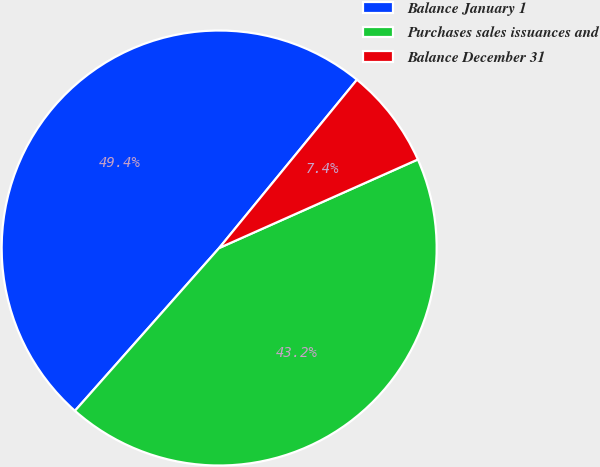<chart> <loc_0><loc_0><loc_500><loc_500><pie_chart><fcel>Balance January 1<fcel>Purchases sales issuances and<fcel>Balance December 31<nl><fcel>49.38%<fcel>43.21%<fcel>7.41%<nl></chart> 